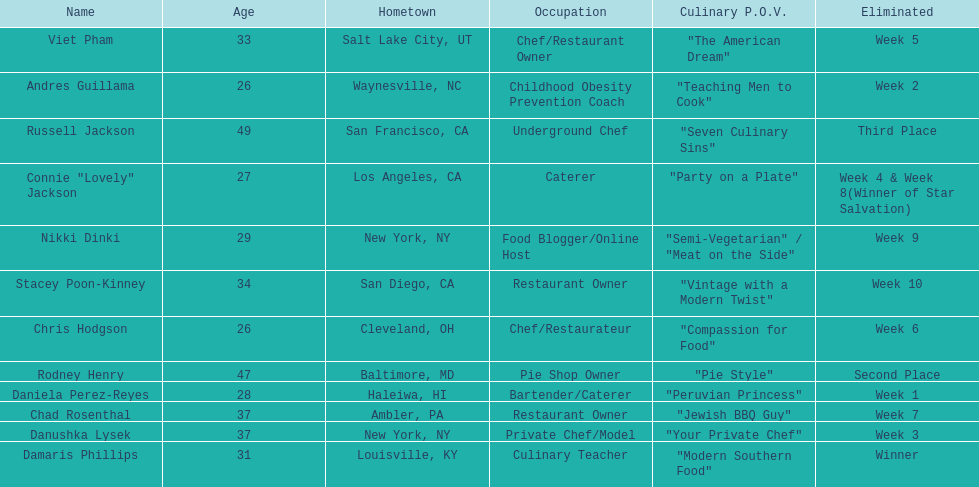Who are all of the contestants? Damaris Phillips, Rodney Henry, Russell Jackson, Stacey Poon-Kinney, Nikki Dinki, Chad Rosenthal, Chris Hodgson, Viet Pham, Connie "Lovely" Jackson, Danushka Lysek, Andres Guillama, Daniela Perez-Reyes. What is each player's culinary point of view? "Modern Southern Food", "Pie Style", "Seven Culinary Sins", "Vintage with a Modern Twist", "Semi-Vegetarian" / "Meat on the Side", "Jewish BBQ Guy", "Compassion for Food", "The American Dream", "Party on a Plate", "Your Private Chef", "Teaching Men to Cook", "Peruvian Princess". And which player's point of view is the longest? Nikki Dinki. 